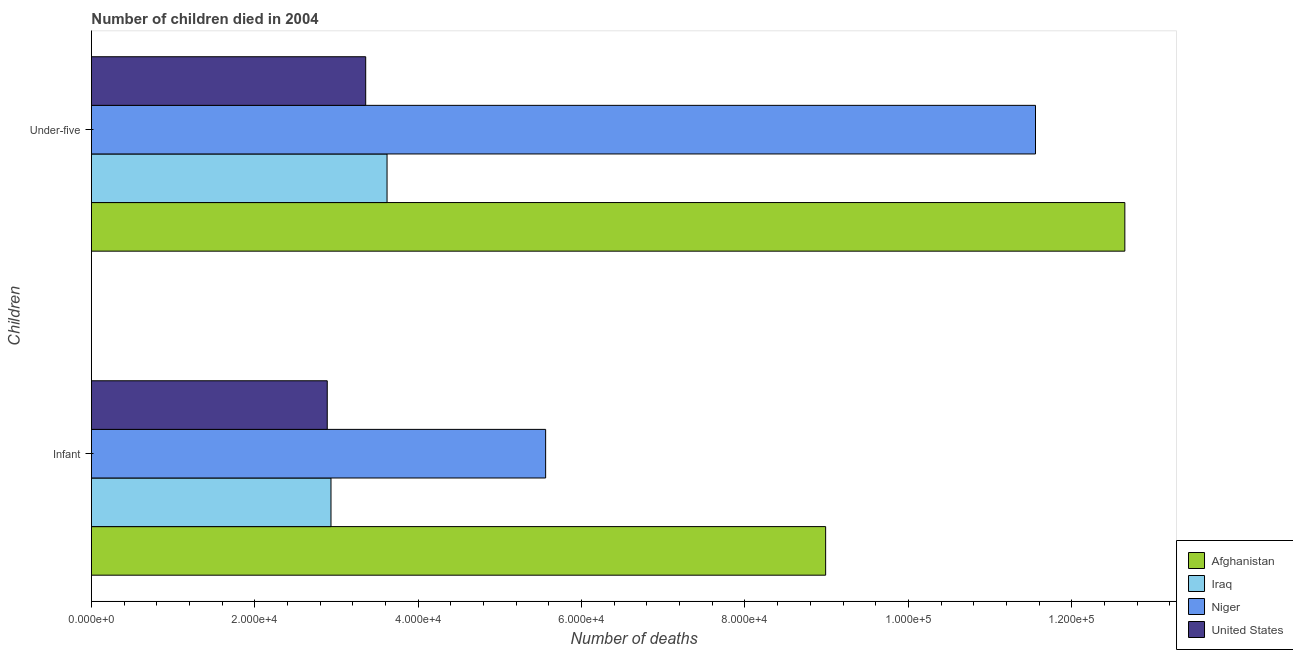How many groups of bars are there?
Your answer should be compact. 2. Are the number of bars per tick equal to the number of legend labels?
Your response must be concise. Yes. Are the number of bars on each tick of the Y-axis equal?
Your answer should be compact. Yes. How many bars are there on the 1st tick from the top?
Offer a very short reply. 4. What is the label of the 2nd group of bars from the top?
Ensure brevity in your answer.  Infant. What is the number of under-five deaths in Niger?
Your answer should be compact. 1.16e+05. Across all countries, what is the maximum number of infant deaths?
Provide a succinct answer. 8.99e+04. Across all countries, what is the minimum number of under-five deaths?
Offer a very short reply. 3.36e+04. In which country was the number of infant deaths maximum?
Offer a terse response. Afghanistan. In which country was the number of infant deaths minimum?
Provide a succinct answer. United States. What is the total number of infant deaths in the graph?
Give a very brief answer. 2.04e+05. What is the difference between the number of infant deaths in Iraq and that in Niger?
Give a very brief answer. -2.63e+04. What is the difference between the number of under-five deaths in Iraq and the number of infant deaths in United States?
Provide a short and direct response. 7319. What is the average number of infant deaths per country?
Your answer should be very brief. 5.09e+04. What is the difference between the number of under-five deaths and number of infant deaths in Iraq?
Provide a short and direct response. 6862. In how many countries, is the number of infant deaths greater than 100000 ?
Provide a succinct answer. 0. What is the ratio of the number of infant deaths in Iraq to that in Afghanistan?
Offer a very short reply. 0.33. Is the number of under-five deaths in Iraq less than that in Afghanistan?
Your answer should be compact. Yes. In how many countries, is the number of infant deaths greater than the average number of infant deaths taken over all countries?
Your response must be concise. 2. What does the 2nd bar from the bottom in Under-five represents?
Your response must be concise. Iraq. How many countries are there in the graph?
Ensure brevity in your answer.  4. Does the graph contain grids?
Your answer should be compact. No. What is the title of the graph?
Provide a short and direct response. Number of children died in 2004. Does "High income: OECD" appear as one of the legend labels in the graph?
Your response must be concise. No. What is the label or title of the X-axis?
Give a very brief answer. Number of deaths. What is the label or title of the Y-axis?
Your response must be concise. Children. What is the Number of deaths in Afghanistan in Infant?
Keep it short and to the point. 8.99e+04. What is the Number of deaths in Iraq in Infant?
Ensure brevity in your answer.  2.93e+04. What is the Number of deaths in Niger in Infant?
Offer a terse response. 5.56e+04. What is the Number of deaths of United States in Infant?
Offer a terse response. 2.89e+04. What is the Number of deaths of Afghanistan in Under-five?
Ensure brevity in your answer.  1.26e+05. What is the Number of deaths of Iraq in Under-five?
Keep it short and to the point. 3.62e+04. What is the Number of deaths of Niger in Under-five?
Your answer should be very brief. 1.16e+05. What is the Number of deaths of United States in Under-five?
Your answer should be very brief. 3.36e+04. Across all Children, what is the maximum Number of deaths in Afghanistan?
Your answer should be compact. 1.26e+05. Across all Children, what is the maximum Number of deaths of Iraq?
Your response must be concise. 3.62e+04. Across all Children, what is the maximum Number of deaths of Niger?
Provide a short and direct response. 1.16e+05. Across all Children, what is the maximum Number of deaths in United States?
Keep it short and to the point. 3.36e+04. Across all Children, what is the minimum Number of deaths of Afghanistan?
Your answer should be very brief. 8.99e+04. Across all Children, what is the minimum Number of deaths in Iraq?
Your response must be concise. 2.93e+04. Across all Children, what is the minimum Number of deaths in Niger?
Provide a short and direct response. 5.56e+04. Across all Children, what is the minimum Number of deaths of United States?
Provide a succinct answer. 2.89e+04. What is the total Number of deaths of Afghanistan in the graph?
Make the answer very short. 2.16e+05. What is the total Number of deaths in Iraq in the graph?
Provide a succinct answer. 6.55e+04. What is the total Number of deaths of Niger in the graph?
Offer a very short reply. 1.71e+05. What is the total Number of deaths of United States in the graph?
Offer a terse response. 6.24e+04. What is the difference between the Number of deaths in Afghanistan in Infant and that in Under-five?
Your answer should be compact. -3.66e+04. What is the difference between the Number of deaths in Iraq in Infant and that in Under-five?
Offer a very short reply. -6862. What is the difference between the Number of deaths of Niger in Infant and that in Under-five?
Offer a very short reply. -6.00e+04. What is the difference between the Number of deaths in United States in Infant and that in Under-five?
Give a very brief answer. -4706. What is the difference between the Number of deaths of Afghanistan in Infant and the Number of deaths of Iraq in Under-five?
Your answer should be compact. 5.37e+04. What is the difference between the Number of deaths of Afghanistan in Infant and the Number of deaths of Niger in Under-five?
Keep it short and to the point. -2.57e+04. What is the difference between the Number of deaths in Afghanistan in Infant and the Number of deaths in United States in Under-five?
Your response must be concise. 5.63e+04. What is the difference between the Number of deaths in Iraq in Infant and the Number of deaths in Niger in Under-five?
Give a very brief answer. -8.62e+04. What is the difference between the Number of deaths of Iraq in Infant and the Number of deaths of United States in Under-five?
Keep it short and to the point. -4249. What is the difference between the Number of deaths of Niger in Infant and the Number of deaths of United States in Under-five?
Your answer should be compact. 2.20e+04. What is the average Number of deaths of Afghanistan per Children?
Offer a very short reply. 1.08e+05. What is the average Number of deaths of Iraq per Children?
Ensure brevity in your answer.  3.28e+04. What is the average Number of deaths in Niger per Children?
Make the answer very short. 8.56e+04. What is the average Number of deaths in United States per Children?
Give a very brief answer. 3.12e+04. What is the difference between the Number of deaths of Afghanistan and Number of deaths of Iraq in Infant?
Provide a succinct answer. 6.05e+04. What is the difference between the Number of deaths in Afghanistan and Number of deaths in Niger in Infant?
Your response must be concise. 3.43e+04. What is the difference between the Number of deaths in Afghanistan and Number of deaths in United States in Infant?
Offer a terse response. 6.10e+04. What is the difference between the Number of deaths of Iraq and Number of deaths of Niger in Infant?
Make the answer very short. -2.63e+04. What is the difference between the Number of deaths of Iraq and Number of deaths of United States in Infant?
Offer a terse response. 457. What is the difference between the Number of deaths in Niger and Number of deaths in United States in Infant?
Provide a succinct answer. 2.67e+04. What is the difference between the Number of deaths in Afghanistan and Number of deaths in Iraq in Under-five?
Ensure brevity in your answer.  9.03e+04. What is the difference between the Number of deaths of Afghanistan and Number of deaths of Niger in Under-five?
Your answer should be compact. 1.09e+04. What is the difference between the Number of deaths in Afghanistan and Number of deaths in United States in Under-five?
Make the answer very short. 9.29e+04. What is the difference between the Number of deaths in Iraq and Number of deaths in Niger in Under-five?
Your response must be concise. -7.94e+04. What is the difference between the Number of deaths in Iraq and Number of deaths in United States in Under-five?
Provide a short and direct response. 2613. What is the difference between the Number of deaths in Niger and Number of deaths in United States in Under-five?
Your response must be concise. 8.20e+04. What is the ratio of the Number of deaths in Afghanistan in Infant to that in Under-five?
Your answer should be compact. 0.71. What is the ratio of the Number of deaths in Iraq in Infant to that in Under-five?
Ensure brevity in your answer.  0.81. What is the ratio of the Number of deaths of Niger in Infant to that in Under-five?
Offer a very short reply. 0.48. What is the ratio of the Number of deaths of United States in Infant to that in Under-five?
Ensure brevity in your answer.  0.86. What is the difference between the highest and the second highest Number of deaths of Afghanistan?
Ensure brevity in your answer.  3.66e+04. What is the difference between the highest and the second highest Number of deaths in Iraq?
Offer a very short reply. 6862. What is the difference between the highest and the second highest Number of deaths in Niger?
Give a very brief answer. 6.00e+04. What is the difference between the highest and the second highest Number of deaths in United States?
Offer a very short reply. 4706. What is the difference between the highest and the lowest Number of deaths of Afghanistan?
Your answer should be very brief. 3.66e+04. What is the difference between the highest and the lowest Number of deaths in Iraq?
Provide a short and direct response. 6862. What is the difference between the highest and the lowest Number of deaths in Niger?
Provide a short and direct response. 6.00e+04. What is the difference between the highest and the lowest Number of deaths in United States?
Your response must be concise. 4706. 